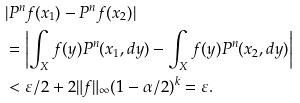Convert formula to latex. <formula><loc_0><loc_0><loc_500><loc_500>& | P ^ { n } f ( x _ { 1 } ) - P ^ { n } f ( x _ { 2 } ) | \\ & = \left | \int _ { X } f ( y ) P ^ { n } ( x _ { 1 } , d y ) - \int _ { X } f ( y ) P ^ { n } ( x _ { 2 } , d y ) \right | \\ & < \varepsilon / 2 + 2 \| f \| _ { \infty } ( 1 - \alpha / 2 ) ^ { k } = \varepsilon .</formula> 